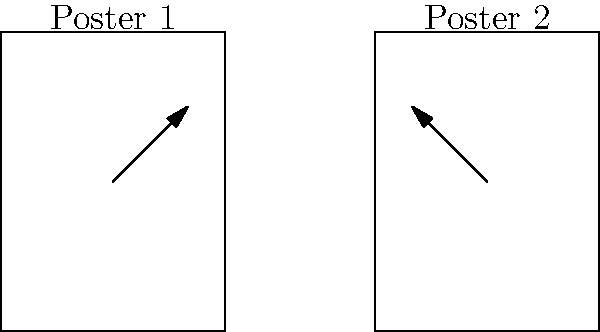Analyze the visual composition of the two mockumentary film posters represented by rectangles. If the vectors shown represent the primary visual flow in each poster, how do they differ in terms of their geometric properties? Consider the direction and magnitude of the vectors in your analysis. To compare the vectors in the two mockumentary film posters, we need to analyze their geometric properties:

1. Direction:
   - Poster 1: The vector points upward and to the right.
   - Poster 2: The vector points upward and to the left.

2. Magnitude:
   - Both vectors appear to have the same length, indicating similar magnitudes.

3. Angle:
   - Poster 1: The vector forms an acute angle with the horizontal, pointing northeast.
   - Poster 2: The vector forms an obtuse angle with the horizontal, pointing northwest.

4. Orientation relative to the poster:
   - Poster 1: The vector moves from the center towards the upper-right corner.
   - Poster 2: The vector moves from the center towards the upper-left corner.

5. Mathematical representation:
   - If we consider the bottom-left corner of each poster as the origin (0,0):
     Poster 1 vector: $\vec{v_1} = (1, 1)$
     Poster 2 vector: $\vec{v_2} = (-1, 1)$

6. Dot product:
   - The dot product of these vectors would be: $\vec{v_1} \cdot \vec{v_2} = (1)(-1) + (1)(1) = 0$
   - This indicates that the vectors are perpendicular to each other.

The key difference lies in the horizontal component of the vectors, which are opposite in direction, creating a mirrored effect between the two posters.
Answer: The vectors have equal magnitudes but opposite horizontal directions, creating a mirrored visual flow between the posters. 